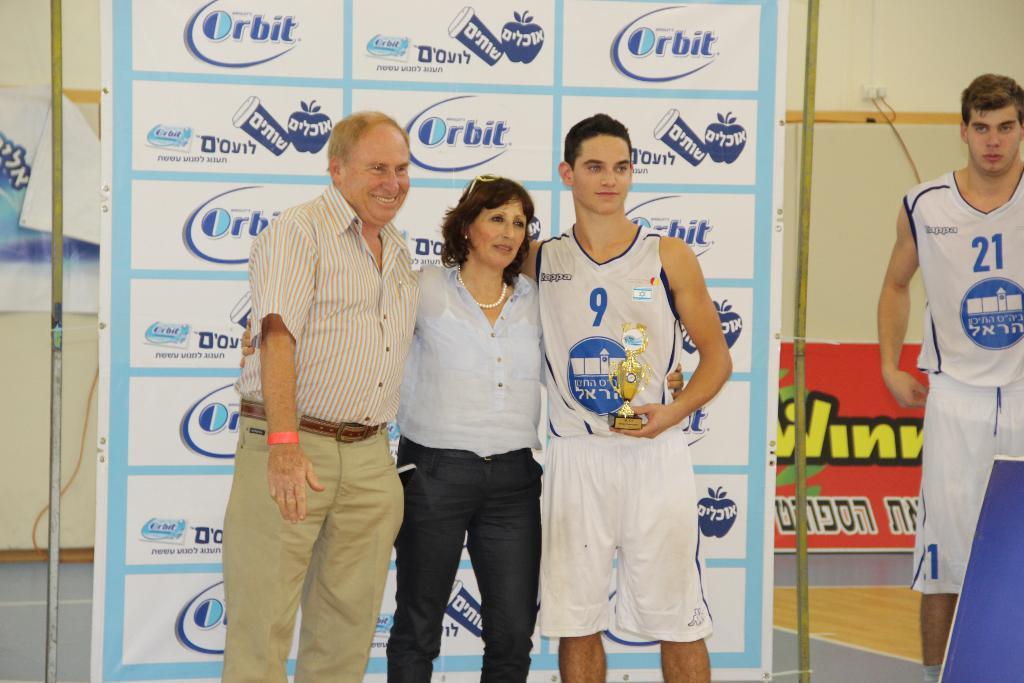What brand of gum is sponsoring this event?
Provide a short and direct response. Orbit. 